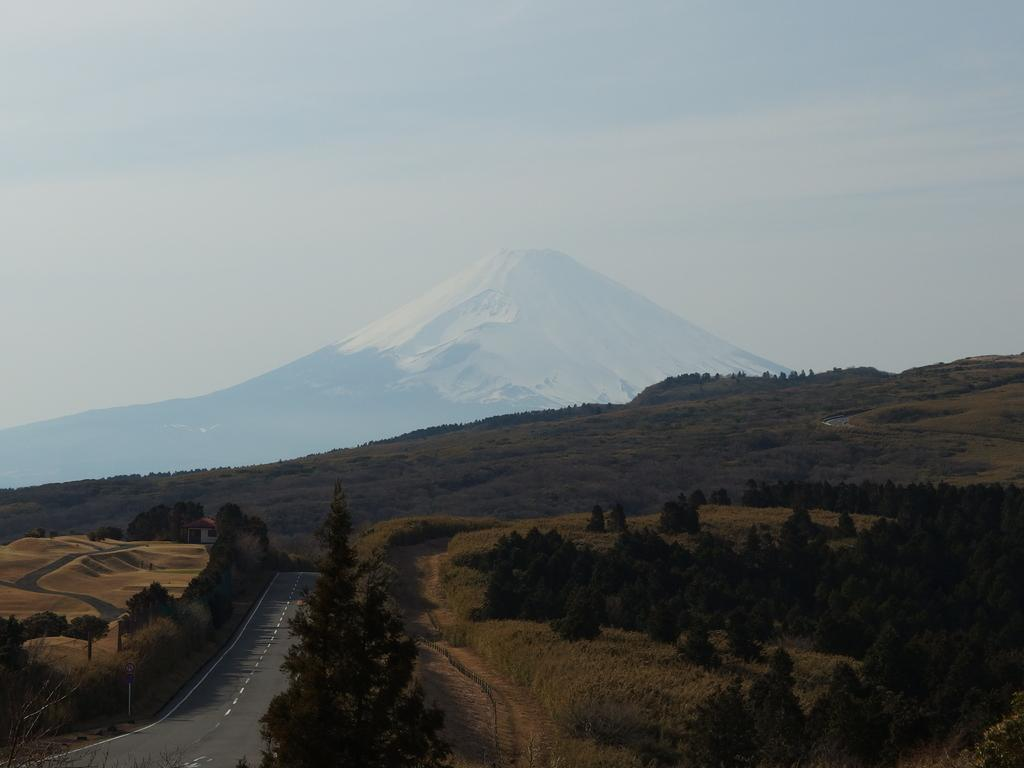What is the main feature of the image? There is a road in the image. What can be seen beside the road? There are many trees beside the road. What else is visible in the background? There are more trees and mountains visible in the background. What is the condition of the sky in the image? Clouds and the sky are visible in the background. Can you see a flock of monkeys sitting on a loaf of bread in the image? There is no flock of monkeys or loaf of bread present in the image. 